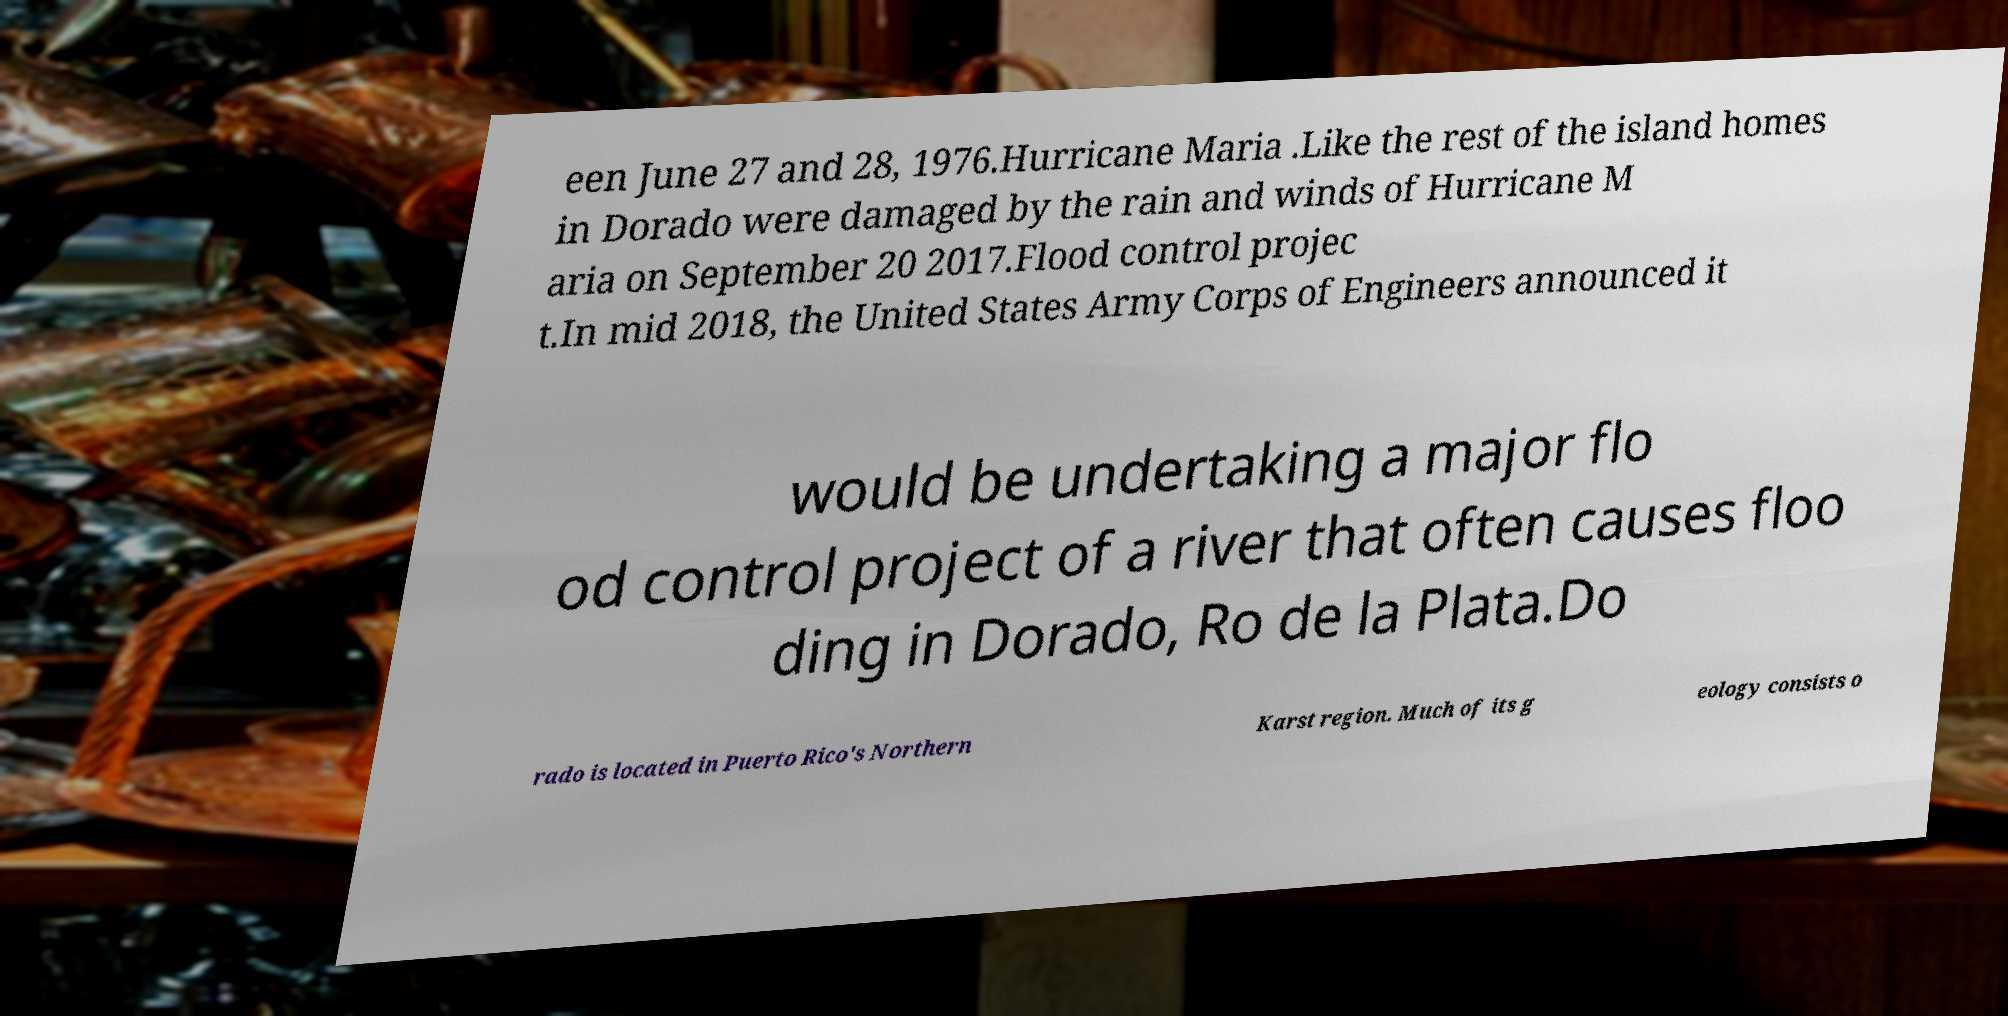Could you assist in decoding the text presented in this image and type it out clearly? een June 27 and 28, 1976.Hurricane Maria .Like the rest of the island homes in Dorado were damaged by the rain and winds of Hurricane M aria on September 20 2017.Flood control projec t.In mid 2018, the United States Army Corps of Engineers announced it would be undertaking a major flo od control project of a river that often causes floo ding in Dorado, Ro de la Plata.Do rado is located in Puerto Rico's Northern Karst region. Much of its g eology consists o 